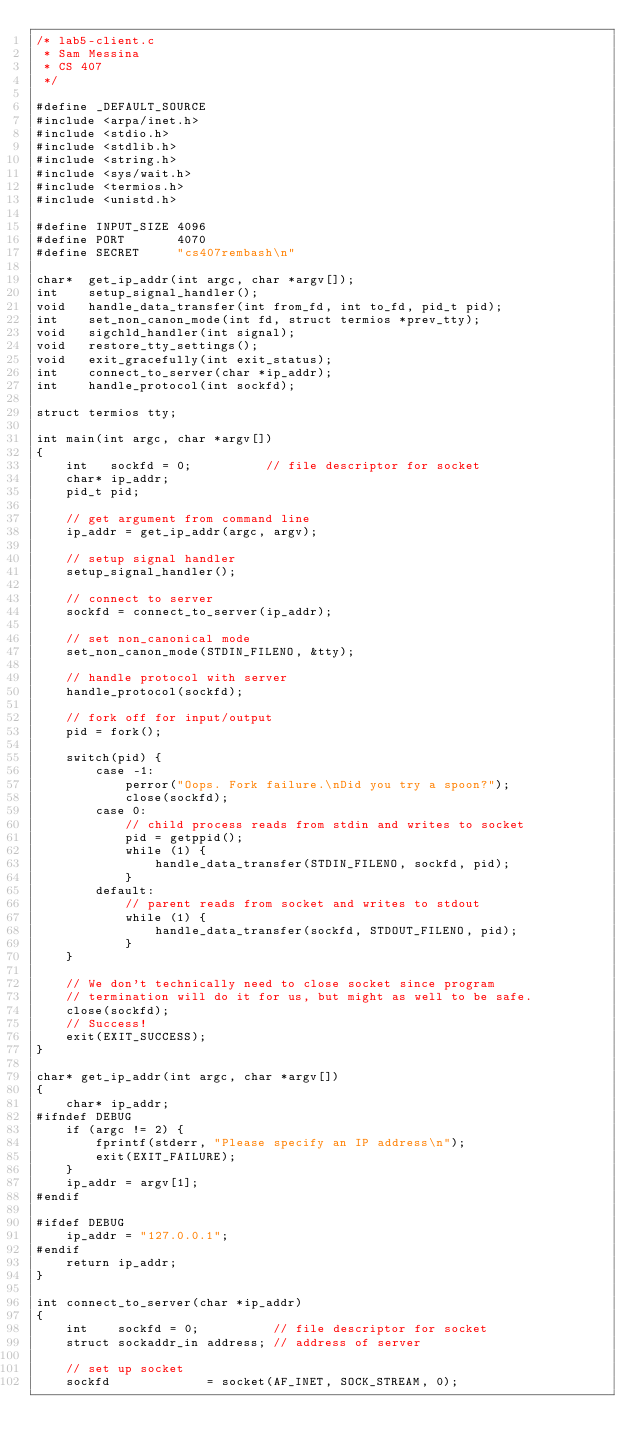<code> <loc_0><loc_0><loc_500><loc_500><_C_>/* lab5-client.c
 * Sam Messina
 * CS 407
 */

#define _DEFAULT_SOURCE
#include <arpa/inet.h>
#include <stdio.h>
#include <stdlib.h>
#include <string.h>
#include <sys/wait.h>
#include <termios.h>
#include <unistd.h>

#define INPUT_SIZE 4096
#define PORT       4070
#define SECRET     "cs407rembash\n"

char*  get_ip_addr(int argc, char *argv[]);
int    setup_signal_handler();
void   handle_data_transfer(int from_fd, int to_fd, pid_t pid);
int    set_non_canon_mode(int fd, struct termios *prev_tty);
void   sigchld_handler(int signal);
void   restore_tty_settings();
void   exit_gracefully(int exit_status);
int    connect_to_server(char *ip_addr);
int    handle_protocol(int sockfd);

struct termios tty;

int main(int argc, char *argv[])
{
    int   sockfd = 0;          // file descriptor for socket
    char* ip_addr;
    pid_t pid;

    // get argument from command line
    ip_addr = get_ip_addr(argc, argv);

    // setup signal handler
    setup_signal_handler();

    // connect to server
    sockfd = connect_to_server(ip_addr);

    // set non_canonical mode
    set_non_canon_mode(STDIN_FILENO, &tty);

    // handle protocol with server
    handle_protocol(sockfd);

    // fork off for input/output
    pid = fork();

    switch(pid) {
        case -1:
            perror("Oops. Fork failure.\nDid you try a spoon?"); 
            close(sockfd);
        case 0:
            // child process reads from stdin and writes to socket
            pid = getppid();
            while (1) {
                handle_data_transfer(STDIN_FILENO, sockfd, pid); 
            }
        default:
            // parent reads from socket and writes to stdout
            while (1) {
                handle_data_transfer(sockfd, STDOUT_FILENO, pid); 
            }
    }

    // We don't technically need to close socket since program 
    // termination will do it for us, but might as well to be safe.
    close(sockfd);
    // Success!
    exit(EXIT_SUCCESS);
}

char* get_ip_addr(int argc, char *argv[]) 
{
    char* ip_addr;
#ifndef DEBUG
    if (argc != 2) {
        fprintf(stderr, "Please specify an IP address\n");
        exit(EXIT_FAILURE);
    }
    ip_addr = argv[1];
#endif

#ifdef DEBUG
    ip_addr = "127.0.0.1";
#endif
    return ip_addr;
}

int connect_to_server(char *ip_addr) 
{
    int    sockfd = 0;          // file descriptor for socket
    struct sockaddr_in address; // address of server

    // set up socket
    sockfd             = socket(AF_INET, SOCK_STREAM, 0);</code> 